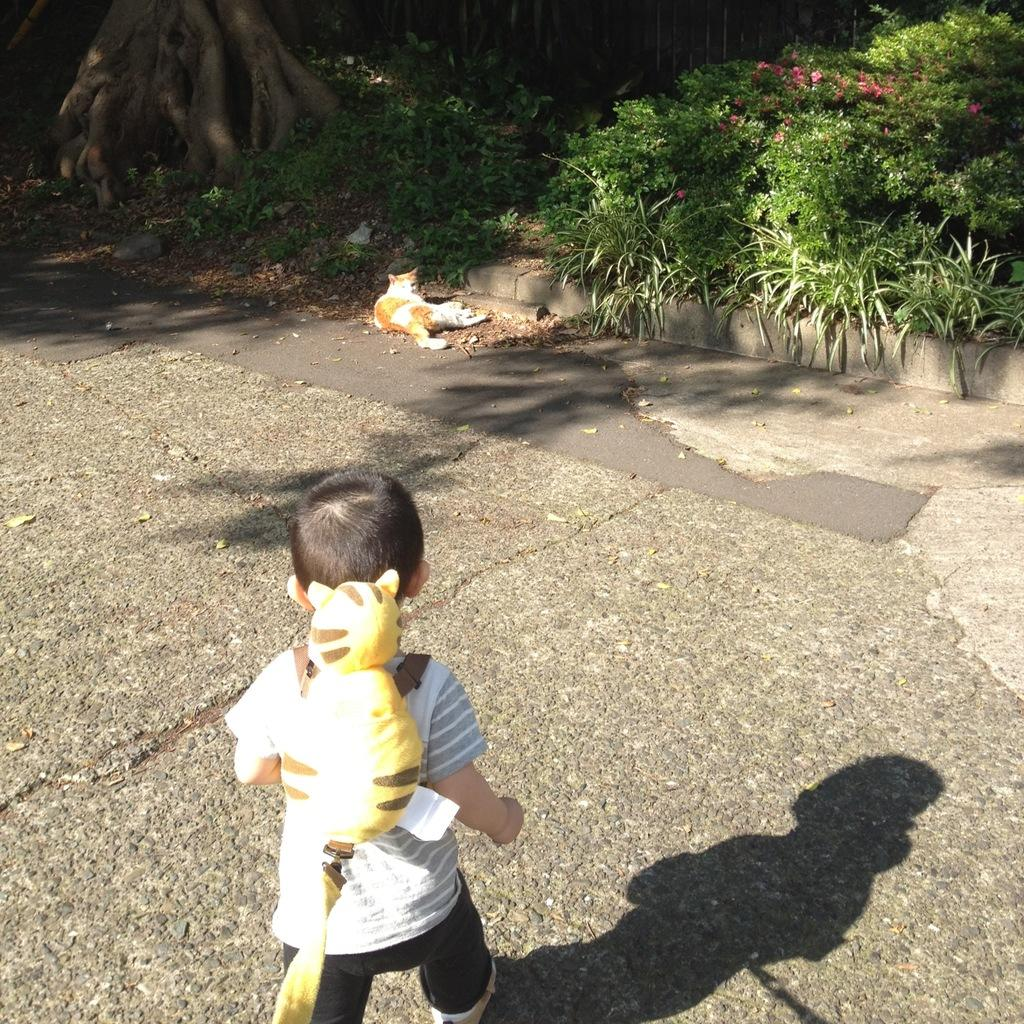Who is the main subject in the image? There is a small boy in the image. What is the boy wearing? The boy is wearing a yellow backpack. What is the boy doing in the image? The boy is running. What other animal is present in the image? There is a cat in the image. Where is the cat located? The cat is sitting in the plants. What can be seen in the background of the image? There are trees and a big tree trunk in the background of the image. What type of quartz can be seen in the image? There is no quartz present in the image. How many pigs are visible in the image? There are no pigs visible in the image. 